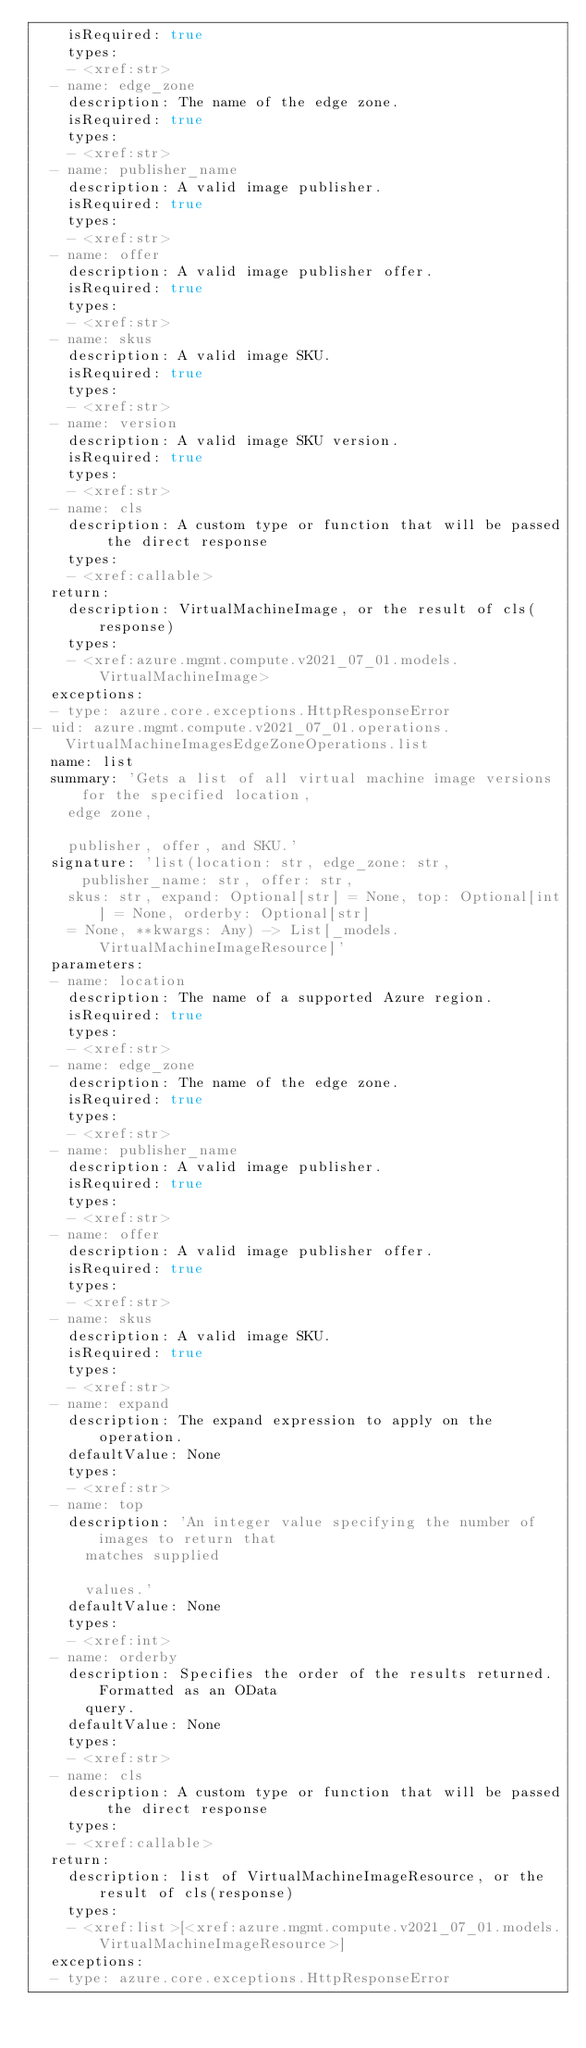Convert code to text. <code><loc_0><loc_0><loc_500><loc_500><_YAML_>    isRequired: true
    types:
    - <xref:str>
  - name: edge_zone
    description: The name of the edge zone.
    isRequired: true
    types:
    - <xref:str>
  - name: publisher_name
    description: A valid image publisher.
    isRequired: true
    types:
    - <xref:str>
  - name: offer
    description: A valid image publisher offer.
    isRequired: true
    types:
    - <xref:str>
  - name: skus
    description: A valid image SKU.
    isRequired: true
    types:
    - <xref:str>
  - name: version
    description: A valid image SKU version.
    isRequired: true
    types:
    - <xref:str>
  - name: cls
    description: A custom type or function that will be passed the direct response
    types:
    - <xref:callable>
  return:
    description: VirtualMachineImage, or the result of cls(response)
    types:
    - <xref:azure.mgmt.compute.v2021_07_01.models.VirtualMachineImage>
  exceptions:
  - type: azure.core.exceptions.HttpResponseError
- uid: azure.mgmt.compute.v2021_07_01.operations.VirtualMachineImagesEdgeZoneOperations.list
  name: list
  summary: 'Gets a list of all virtual machine image versions for the specified location,
    edge zone,

    publisher, offer, and SKU.'
  signature: 'list(location: str, edge_zone: str, publisher_name: str, offer: str,
    skus: str, expand: Optional[str] = None, top: Optional[int] = None, orderby: Optional[str]
    = None, **kwargs: Any) -> List[_models.VirtualMachineImageResource]'
  parameters:
  - name: location
    description: The name of a supported Azure region.
    isRequired: true
    types:
    - <xref:str>
  - name: edge_zone
    description: The name of the edge zone.
    isRequired: true
    types:
    - <xref:str>
  - name: publisher_name
    description: A valid image publisher.
    isRequired: true
    types:
    - <xref:str>
  - name: offer
    description: A valid image publisher offer.
    isRequired: true
    types:
    - <xref:str>
  - name: skus
    description: A valid image SKU.
    isRequired: true
    types:
    - <xref:str>
  - name: expand
    description: The expand expression to apply on the operation.
    defaultValue: None
    types:
    - <xref:str>
  - name: top
    description: 'An integer value specifying the number of images to return that
      matches supplied

      values.'
    defaultValue: None
    types:
    - <xref:int>
  - name: orderby
    description: Specifies the order of the results returned. Formatted as an OData
      query.
    defaultValue: None
    types:
    - <xref:str>
  - name: cls
    description: A custom type or function that will be passed the direct response
    types:
    - <xref:callable>
  return:
    description: list of VirtualMachineImageResource, or the result of cls(response)
    types:
    - <xref:list>[<xref:azure.mgmt.compute.v2021_07_01.models.VirtualMachineImageResource>]
  exceptions:
  - type: azure.core.exceptions.HttpResponseError</code> 